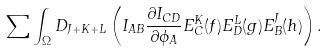<formula> <loc_0><loc_0><loc_500><loc_500>\sum \int _ { \Omega } D _ { J + K + L } \left ( I _ { A B } { \frac { \partial I _ { C D } } { \partial \phi _ { A } } } E _ { C } ^ { K } ( f ) E _ { D } ^ { L } ( g ) E _ { B } ^ { J } ( h ) \right ) .</formula> 